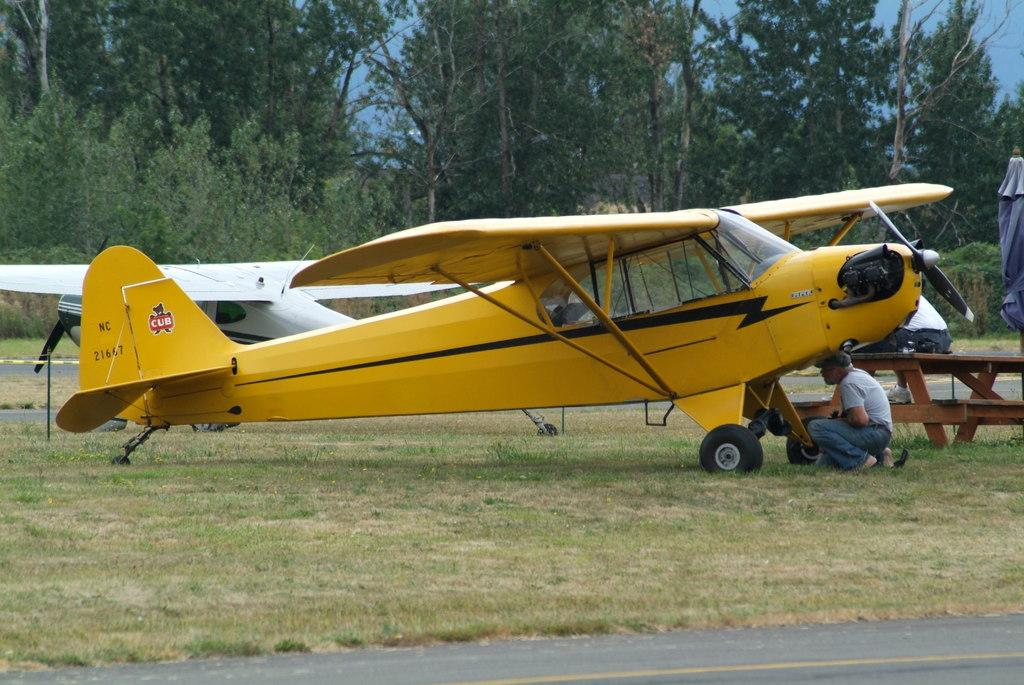What color is the plane in the image? The plane in the image is yellow. What can be seen in the background of the image? There are trees in the background of the image. What statement can be found in the pocket of the plane in the image? There is no statement or pocket present in the image, as it features a yellow plane and trees in the background. 